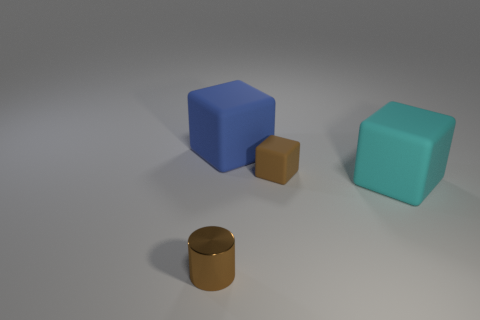Is there anything else that is the same material as the tiny brown cylinder?
Give a very brief answer. No. The other big thing that is the same material as the cyan thing is what color?
Keep it short and to the point. Blue. Are there any cubes of the same size as the brown metallic cylinder?
Keep it short and to the point. Yes. There is a large rubber block on the right side of the big blue rubber thing; does it have the same color as the small matte thing?
Keep it short and to the point. No. What is the color of the object that is in front of the large blue thing and to the left of the small brown rubber cube?
Provide a succinct answer. Brown. There is a matte object that is the same size as the blue matte cube; what shape is it?
Keep it short and to the point. Cube. Is there another red thing of the same shape as the tiny matte object?
Offer a very short reply. No. Does the brown object in front of the brown cube have the same size as the big blue matte cube?
Ensure brevity in your answer.  No. What is the size of the thing that is in front of the brown rubber block and left of the cyan thing?
Your answer should be very brief. Small. How many other objects are the same material as the cylinder?
Provide a succinct answer. 0. 